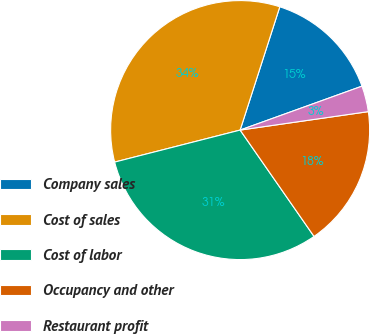Convert chart. <chart><loc_0><loc_0><loc_500><loc_500><pie_chart><fcel>Company sales<fcel>Cost of sales<fcel>Cost of labor<fcel>Occupancy and other<fcel>Restaurant profit<nl><fcel>14.54%<fcel>33.93%<fcel>30.69%<fcel>17.61%<fcel>3.23%<nl></chart> 